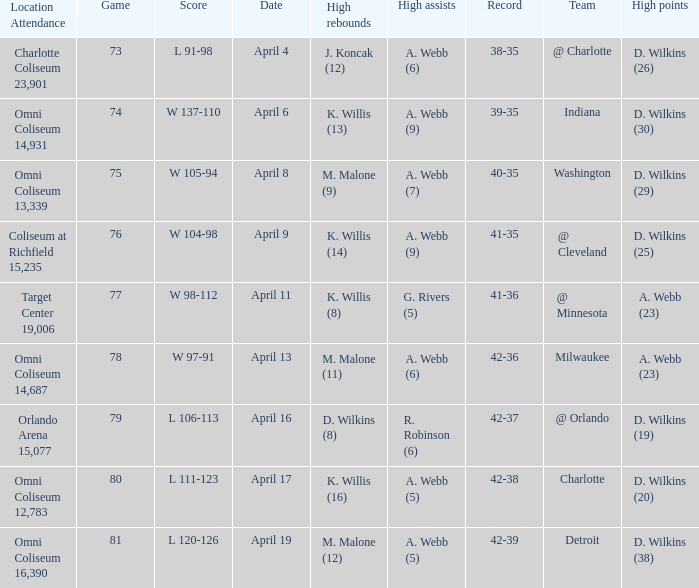How many people had the high points when a. webb (7) had the high assists? 1.0. 